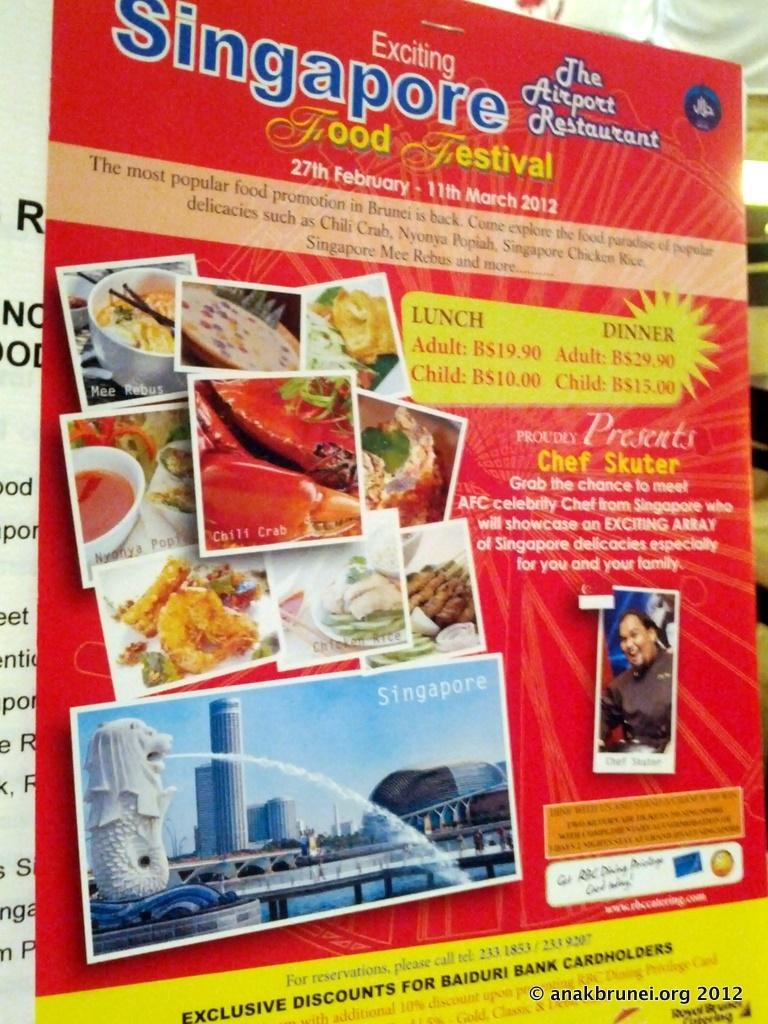What type of paper is the image? The image is an advertisement paper for a restaurant. Where is the restaurant located? The restaurant is located in Singapore. What can be seen on the paper besides the restaurant's information? The paper contains images of food items and displays prices of the food. What other information related to the restaurant is included on the paper? The paper includes other information related to the restaurant. What is the condition of the crate in the image? There is no crate present in the image. What is your opinion on the food items displayed on the paper? The provided facts do not include any information about the food items' quality or taste, so it is impossible to form an opinion based on the image alone. 